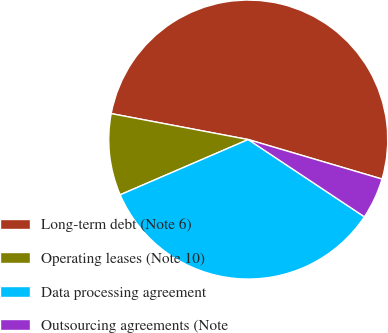<chart> <loc_0><loc_0><loc_500><loc_500><pie_chart><fcel>Long-term debt (Note 6)<fcel>Operating leases (Note 10)<fcel>Data processing agreement<fcel>Outsourcing agreements (Note<nl><fcel>51.59%<fcel>9.46%<fcel>34.18%<fcel>4.77%<nl></chart> 